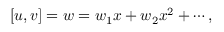<formula> <loc_0><loc_0><loc_500><loc_500>[ u , v ] = w = w _ { 1 } x + w _ { 2 } x ^ { 2 } + \cdots ,</formula> 